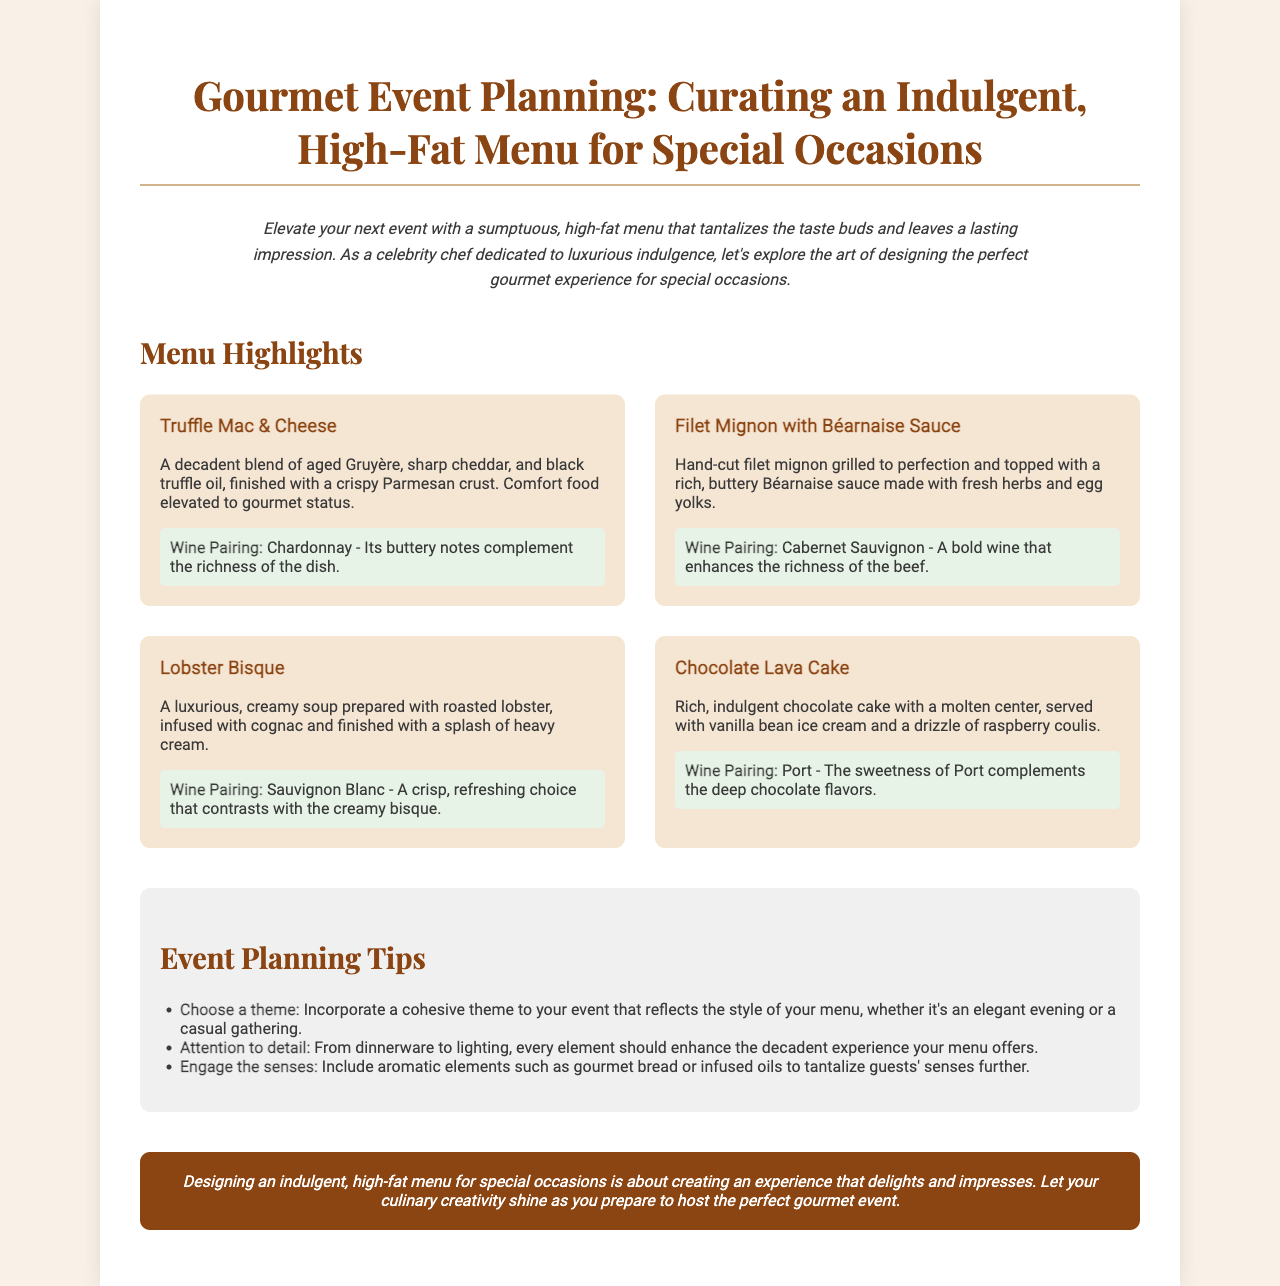What is the title of the brochure? The title of the brochure is the main heading, which introduces the topic of the document.
Answer: Gourmet Event Planning: Curating an Indulgent, High-Fat Menu for Special Occasions How many menu items are highlighted? The number of menu items can be counted in the menu highlights section of the brochure.
Answer: 4 What is the wine pairing for the Truffle Mac & Cheese? The wine pairing is listed in context with the dish in the menu highlights.
Answer: Chardonnay Which dessert is featured in the brochure? The featured dessert is found in the menu highlights among the various dish descriptions.
Answer: Chocolate Lava Cake What key element should enhance the event experience according to the tips? The tips section provides suggestions on elements that can enhance guest experience during events.
Answer: Attention to detail Which wine is paired with the Filet Mignon? The wine pairing is specifically mentioned alongside the description of the main course.
Answer: Cabernet Sauvignon What should the event theme reflect? The tips section highlights how the theme of the event should relate to the overall menu.
Answer: The style of your menu What aromatic elements can be included to engage the senses? The tips section suggests specific items that can be used to engage guests' senses.
Answer: Gourmet bread or infused oils What is the color scheme of the brochure's background? The background color of the document is specified in the style section of the HTML code.
Answer: #f9f1e7 